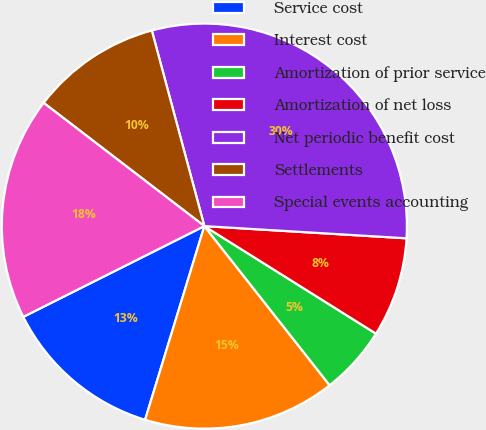Convert chart. <chart><loc_0><loc_0><loc_500><loc_500><pie_chart><fcel>Service cost<fcel>Interest cost<fcel>Amortization of prior service<fcel>Amortization of net loss<fcel>Net periodic benefit cost<fcel>Settlements<fcel>Special events accounting<nl><fcel>12.88%<fcel>15.34%<fcel>5.48%<fcel>7.95%<fcel>30.14%<fcel>10.41%<fcel>17.81%<nl></chart> 